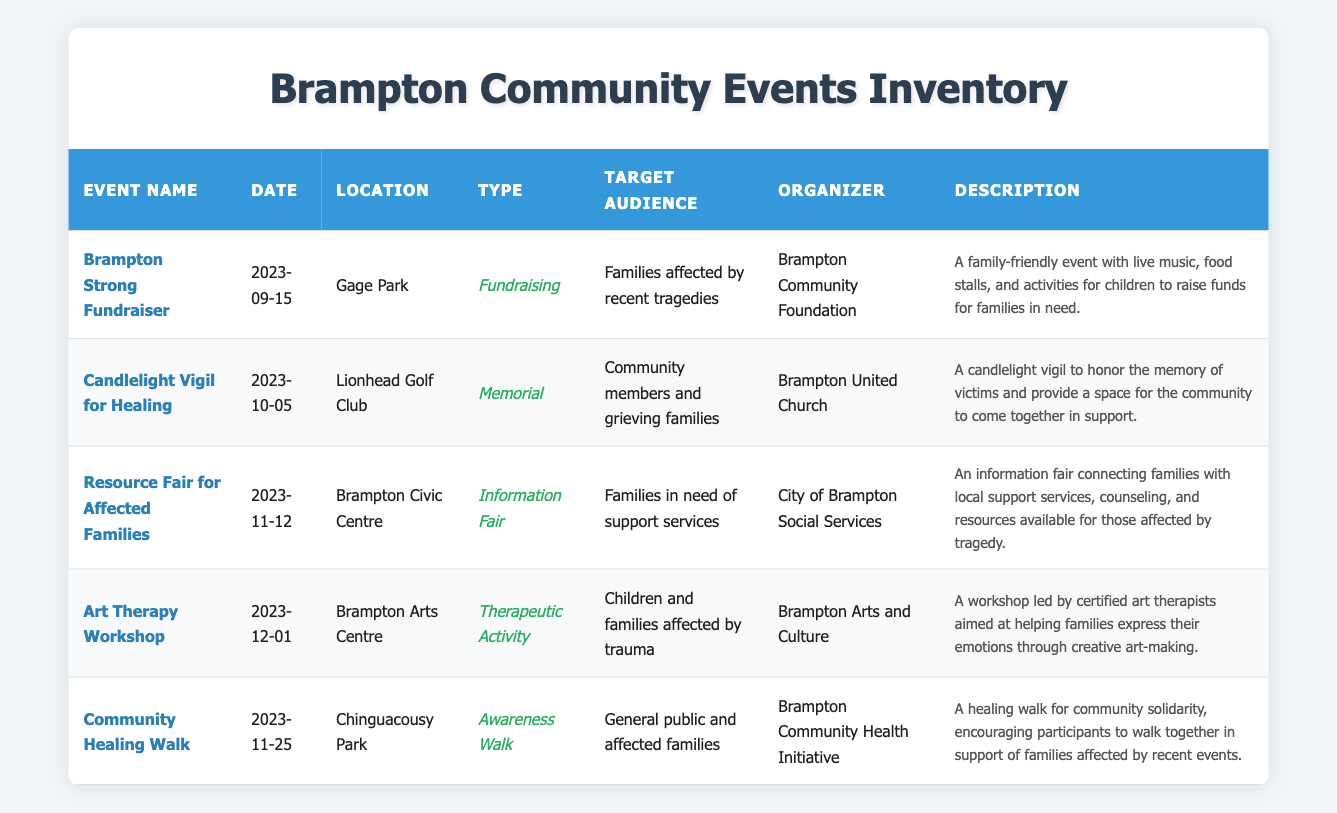What is the date of the "Brampton Strong Fundraiser"? According to the table, the “Brampton Strong Fundraiser” is scheduled for “2023-09-15”.
Answer: 2023-09-15 Which event is organized by the "Brampton United Church"? The table indicates that the event organized by the “Brampton United Church” is the “Candlelight Vigil for Healing”.
Answer: Candlelight Vigil for Healing How many events are explicitly aimed at families affected by recent tragedies? There are two events aimed explicitly at families affected by recent tragedies: “Brampton Strong Fundraiser” and “Art Therapy Workshop”.
Answer: 2 Is there an event scheduled before November 2023? Yes, the “Brampton Strong Fundraiser” and “Candlelight Vigil for Healing” are both scheduled before November 2023.
Answer: Yes Which event at Gage Park is focused on raising funds for families in need? The event at Gage Park that focuses on raising funds for families in need is the “Brampton Strong Fundraiser”.
Answer: Brampton Strong Fundraiser What types of events are listed for November 2023, and what are their purposes? In November 2023, there are two events: “Resource Fair for Affected Families” (Information Fair) aimed at connecting families with support services and “Community Healing Walk” (Awareness Walk) promoting community solidarity.
Answer: Resource Fair for Affected Families and Community Healing Walk What is the primary target audience for the "Art Therapy Workshop"? The primary target audience for the “Art Therapy Workshop” is “Children and families affected by trauma”.
Answer: Children and families affected by trauma How many of the events listed are memorials? There is one event categorized as a memorial, which is the “Candlelight Vigil for Healing”.
Answer: 1 What is the location of the "Resource Fair for Affected Families"? The "Resource Fair for Affected Families" is being held at the "Brampton Civic Centre".
Answer: Brampton Civic Centre 